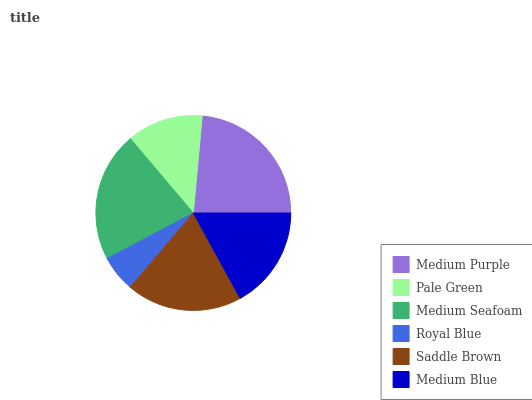Is Royal Blue the minimum?
Answer yes or no. Yes. Is Medium Purple the maximum?
Answer yes or no. Yes. Is Pale Green the minimum?
Answer yes or no. No. Is Pale Green the maximum?
Answer yes or no. No. Is Medium Purple greater than Pale Green?
Answer yes or no. Yes. Is Pale Green less than Medium Purple?
Answer yes or no. Yes. Is Pale Green greater than Medium Purple?
Answer yes or no. No. Is Medium Purple less than Pale Green?
Answer yes or no. No. Is Saddle Brown the high median?
Answer yes or no. Yes. Is Medium Blue the low median?
Answer yes or no. Yes. Is Medium Blue the high median?
Answer yes or no. No. Is Pale Green the low median?
Answer yes or no. No. 